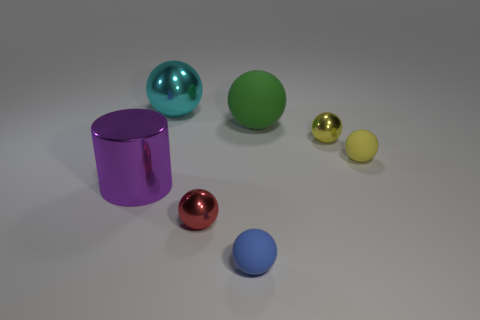There is a object to the left of the shiny sphere that is left of the metallic ball that is in front of the small yellow matte ball; what is its material?
Your answer should be very brief. Metal. There is a yellow object that is to the right of the yellow metal thing; what is it made of?
Your answer should be very brief. Rubber. Is there a red metallic thing that has the same size as the purple object?
Keep it short and to the point. No. How many red objects are either metallic objects or small balls?
Your answer should be very brief. 1. Does the small blue sphere have the same material as the small red ball?
Ensure brevity in your answer.  No. How many large metallic cylinders are in front of the large ball that is to the left of the tiny red metal thing?
Offer a terse response. 1. Does the metal cylinder have the same size as the red thing?
Make the answer very short. No. How many blue things are the same material as the cyan sphere?
Your answer should be compact. 0. There is a blue rubber thing that is the same shape as the yellow matte object; what size is it?
Offer a very short reply. Small. There is a matte object on the left side of the big green rubber ball; is its shape the same as the large matte object?
Provide a succinct answer. Yes. 